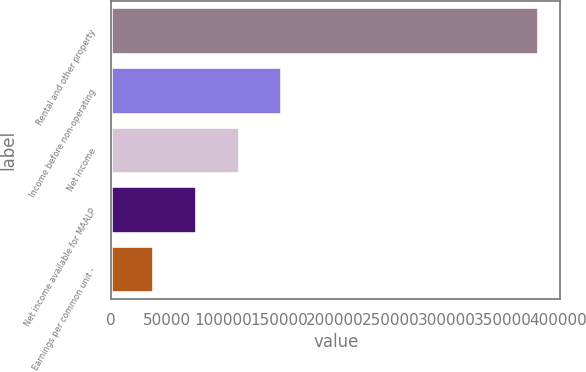<chart> <loc_0><loc_0><loc_500><loc_500><bar_chart><fcel>Rental and other property<fcel>Income before non-operating<fcel>Net income<fcel>Net income available for MAALP<fcel>Earnings per common unit -<nl><fcel>382791<fcel>153117<fcel>114838<fcel>76558.5<fcel>38279.5<nl></chart> 